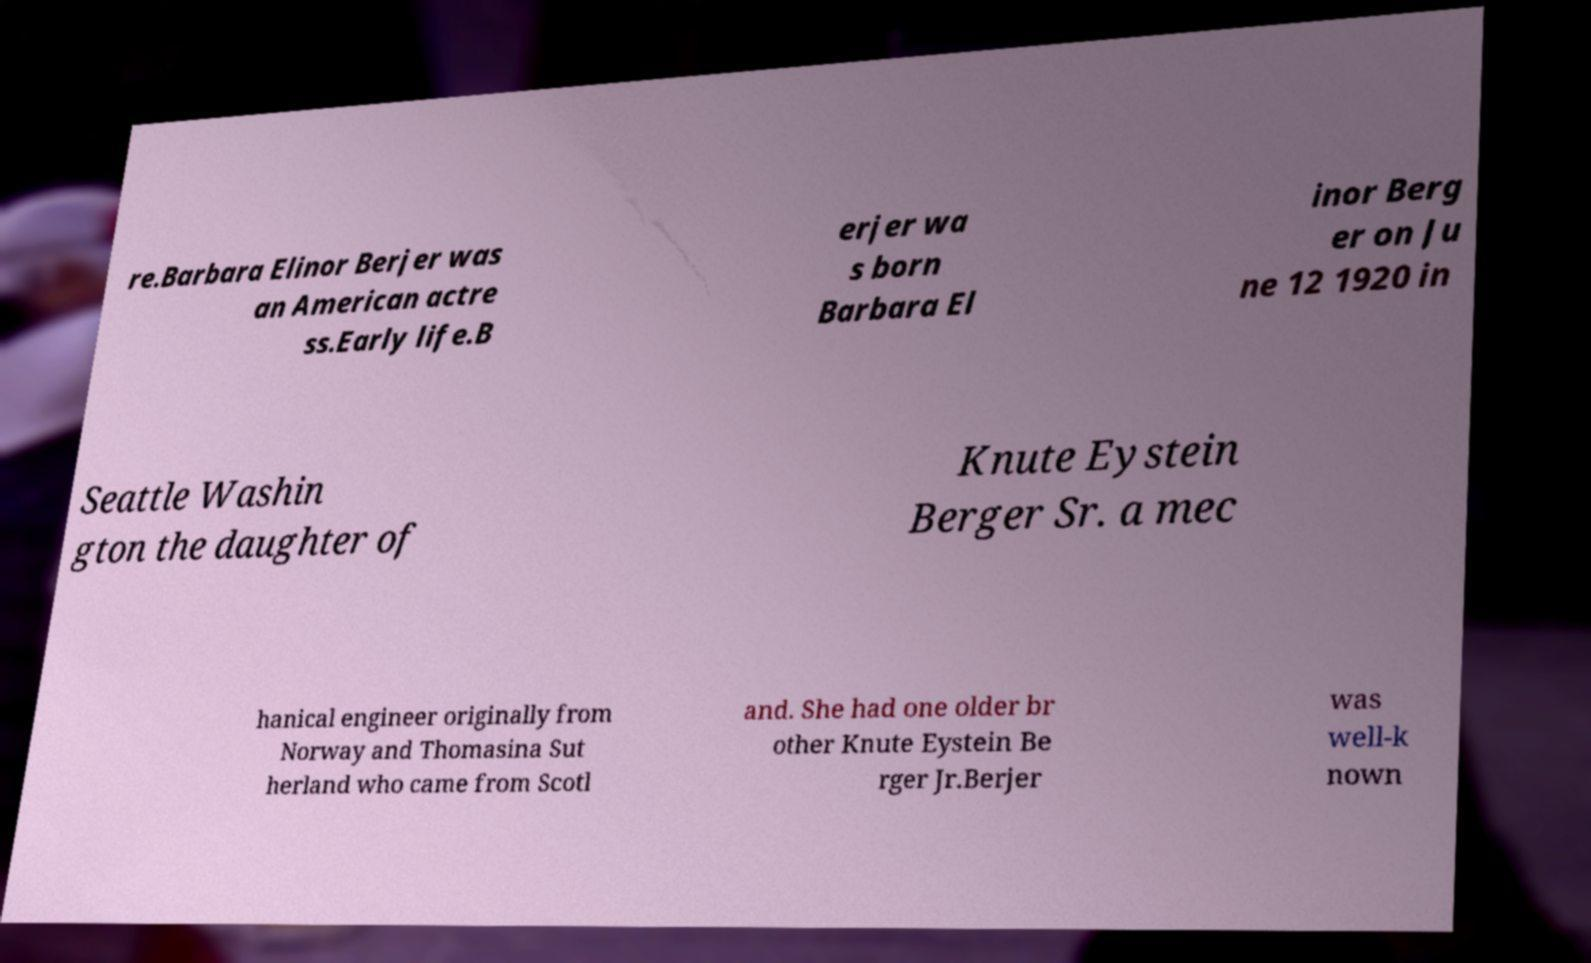Please read and relay the text visible in this image. What does it say? re.Barbara Elinor Berjer was an American actre ss.Early life.B erjer wa s born Barbara El inor Berg er on Ju ne 12 1920 in Seattle Washin gton the daughter of Knute Eystein Berger Sr. a mec hanical engineer originally from Norway and Thomasina Sut herland who came from Scotl and. She had one older br other Knute Eystein Be rger Jr.Berjer was well-k nown 